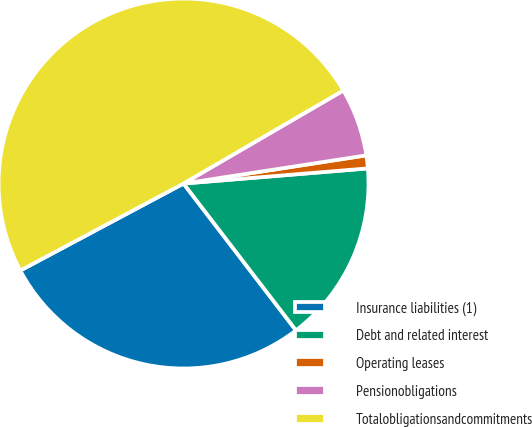<chart> <loc_0><loc_0><loc_500><loc_500><pie_chart><fcel>Insurance liabilities (1)<fcel>Debt and related interest<fcel>Operating leases<fcel>Pensionobligations<fcel>Totalobligationsandcommitments<nl><fcel>27.61%<fcel>15.9%<fcel>1.13%<fcel>5.96%<fcel>49.4%<nl></chart> 